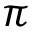<formula> <loc_0><loc_0><loc_500><loc_500>\pi</formula> 